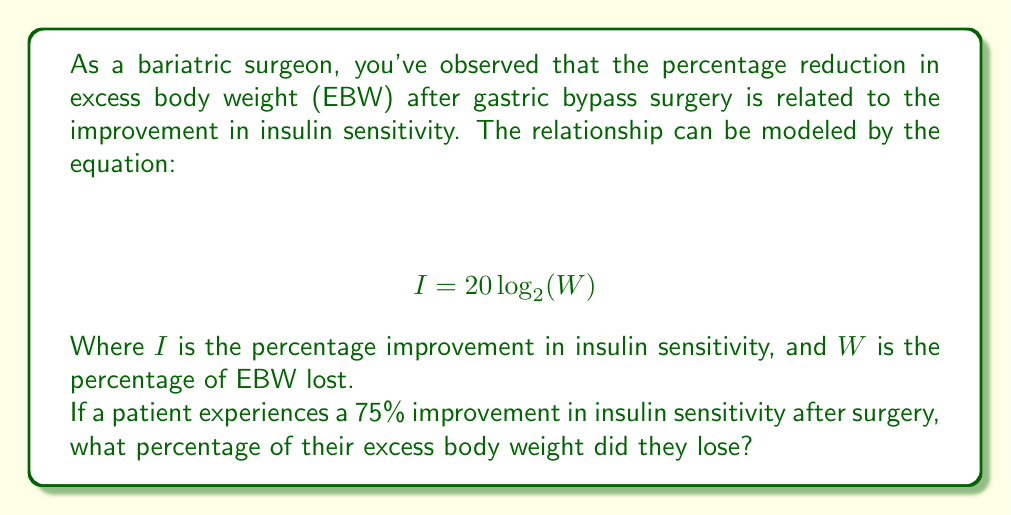Solve this math problem. To solve this problem, we need to use the given logarithmic equation and work backwards to find $W$. Let's approach this step-by-step:

1) We're given the equation: $I = 20 \log_{2}(W)$

2) We know that $I = 75$ (75% improvement in insulin sensitivity). Let's substitute this:

   $75 = 20 \log_{2}(W)$

3) To isolate $W$, we first divide both sides by 20:

   $\frac{75}{20} = \log_{2}(W)$

4) Simplify:

   $3.75 = \log_{2}(W)$

5) To remove the logarithm, we can use the inverse function (exponential) with base 2 on both sides:

   $2^{3.75} = 2^{\log_{2}(W)}$

6) The right side simplifies to just $W$:

   $2^{3.75} = W$

7) Now we just need to calculate $2^{3.75}$:

   $W = 2^{3.75} \approx 13.4543$

8) Convert to a percentage by multiplying by 100:

   $W \approx 1345.43\%$

Therefore, the patient lost approximately 1345.43% of their excess body weight.
Answer: The patient lost approximately 1345.43% of their excess body weight. 